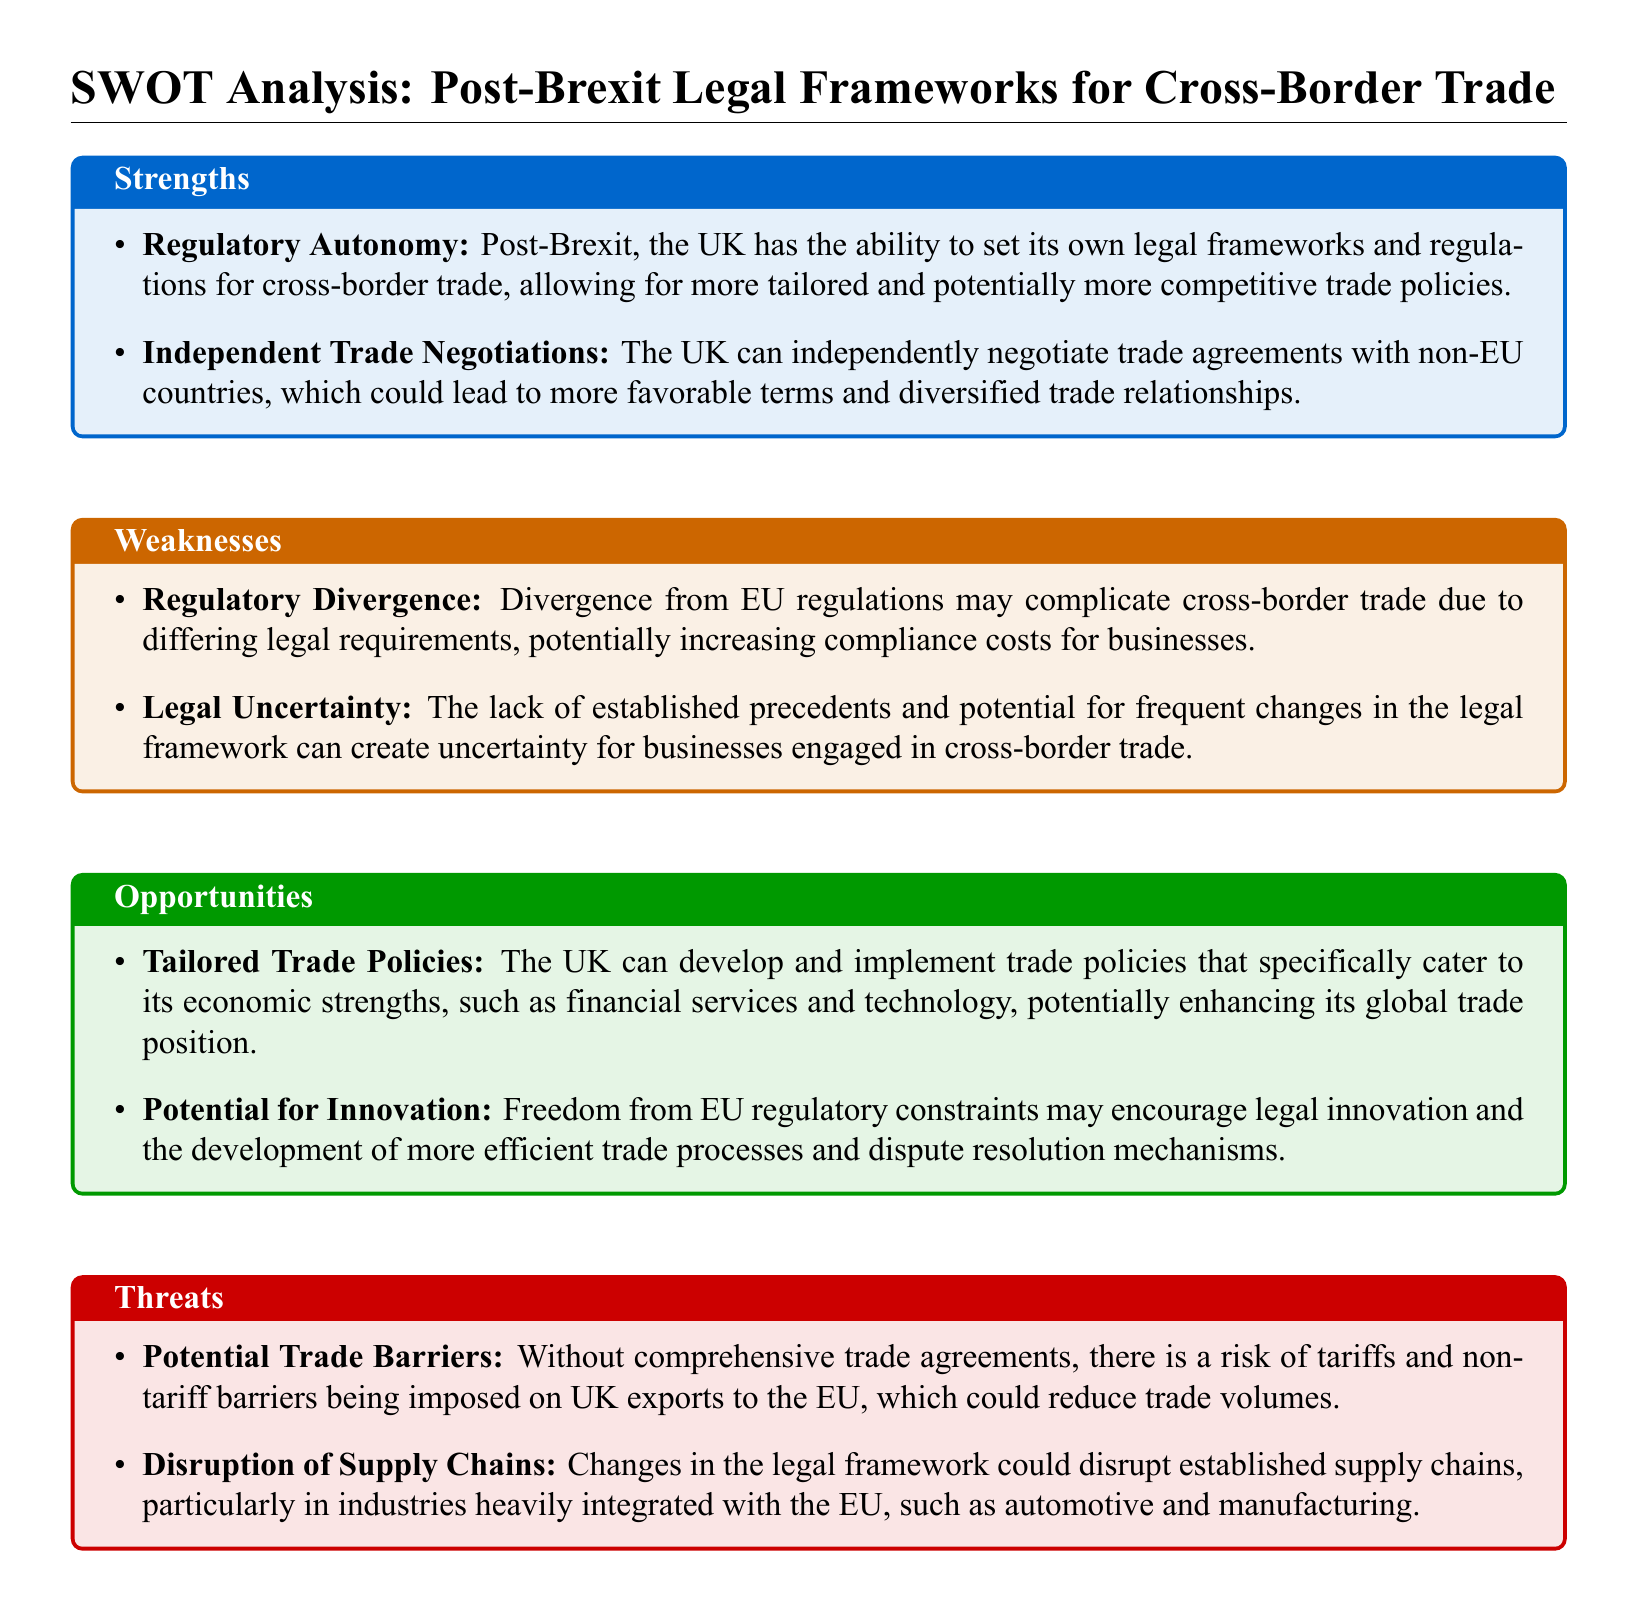What is a strength of the post-Brexit legal framework? The document states that a strength is "Regulatory Autonomy," which allows the UK to set its own legal frameworks and regulations for cross-border trade.
Answer: Regulatory Autonomy What is one potential threat mentioned in the document? The potential threat discussed is "Potential Trade Barriers" due to the absence of comprehensive trade agreements post-Brexit.
Answer: Potential Trade Barriers How many weaknesses are identified in the document? The document lists two weaknesses under the Weaknesses section concerning the post-Brexit legal frameworks for cross-border trade.
Answer: 2 What opportunity can the UK potentially develop according to the document? The document highlights "Tailored Trade Policies" as an opportunity for the UK to implement specific trade policies catering to its economic strengths.
Answer: Tailored Trade Policies What does the document say about legal uncertainty? The document lists "Legal Uncertainty" as a weakness, indicating that it can create uncertainty for businesses engaged in cross-border trade.
Answer: Legal Uncertainty Which industries are mentioned as being potentially disrupted by the changes in the legal framework? The document specifies that industries heavily integrated with the EU, such as "automotive and manufacturing," could experience disruption in their supply chains.
Answer: automotive and manufacturing What is one of the strengths of post-Brexit frameworks mentioned regarding trade agreements? One identified strength is "Independent Trade Negotiations," allowing the UK to negotiate its trade agreements independently.
Answer: Independent Trade Negotiations What is a potential benefit of freedom from EU regulatory constraints as mentioned in the document? The document points out that this freedom may encourage "legal innovation" and the development of more efficient trade processes.
Answer: legal innovation 